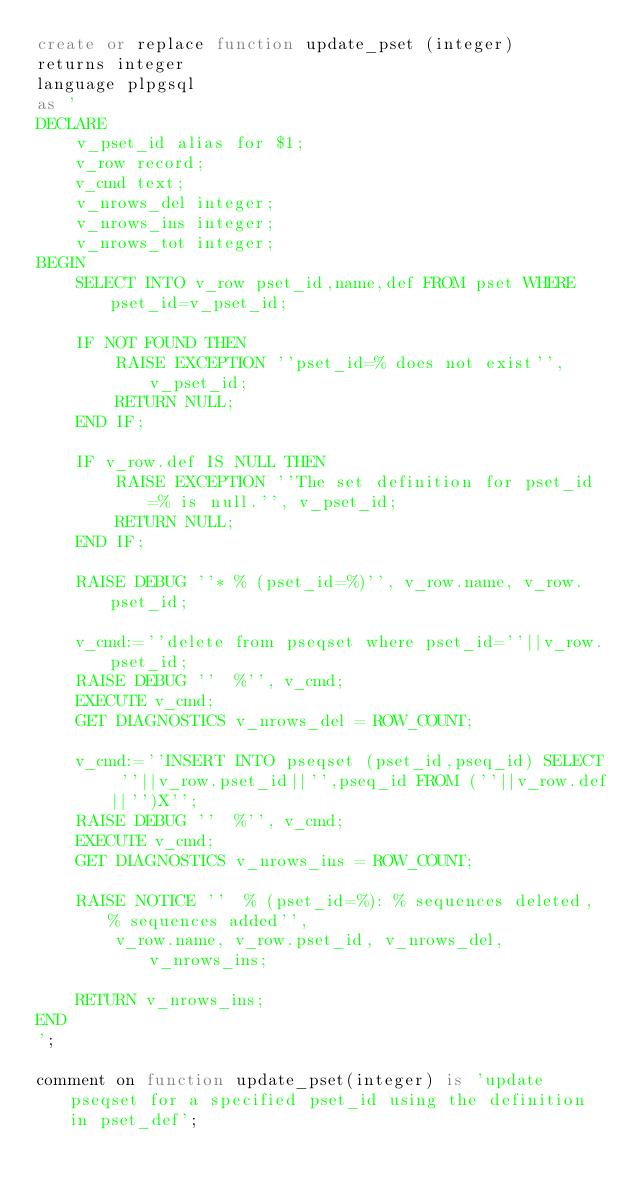<code> <loc_0><loc_0><loc_500><loc_500><_SQL_>create or replace function update_pset (integer)
returns integer
language plpgsql
as '
DECLARE
	v_pset_id alias for $1;
	v_row record;
    v_cmd text;
    v_nrows_del integer;
    v_nrows_ins integer;
    v_nrows_tot integer;
BEGIN
	SELECT INTO v_row pset_id,name,def FROM pset WHERE pset_id=v_pset_id;

	IF NOT FOUND THEN
		RAISE EXCEPTION ''pset_id=% does not exist'', v_pset_id;
		RETURN NULL;
	END IF;

	IF v_row.def IS NULL THEN
		RAISE EXCEPTION ''The set definition for pset_id=% is null.'', v_pset_id;
		RETURN NULL;
	END IF;

	RAISE DEBUG ''* % (pset_id=%)'', v_row.name, v_row.pset_id;

	v_cmd:=''delete from pseqset where pset_id=''||v_row.pset_id;
	RAISE DEBUG ''  %'', v_cmd;
	EXECUTE v_cmd;
	GET DIAGNOSTICS v_nrows_del = ROW_COUNT;

	v_cmd:=''INSERT INTO pseqset (pset_id,pseq_id) SELECT ''||v_row.pset_id||'',pseq_id FROM (''||v_row.def||'')X'';
	RAISE DEBUG ''  %'', v_cmd;
	EXECUTE v_cmd;
	GET DIAGNOSTICS v_nrows_ins = ROW_COUNT;

	RAISE NOTICE ''  % (pset_id=%): % sequences deleted, % sequences added'',
		v_row.name, v_row.pset_id, v_nrows_del, v_nrows_ins;

	RETURN v_nrows_ins;
END
';

comment on function update_pset(integer) is 'update pseqset for a specified pset_id using the definition in pset_def';

</code> 